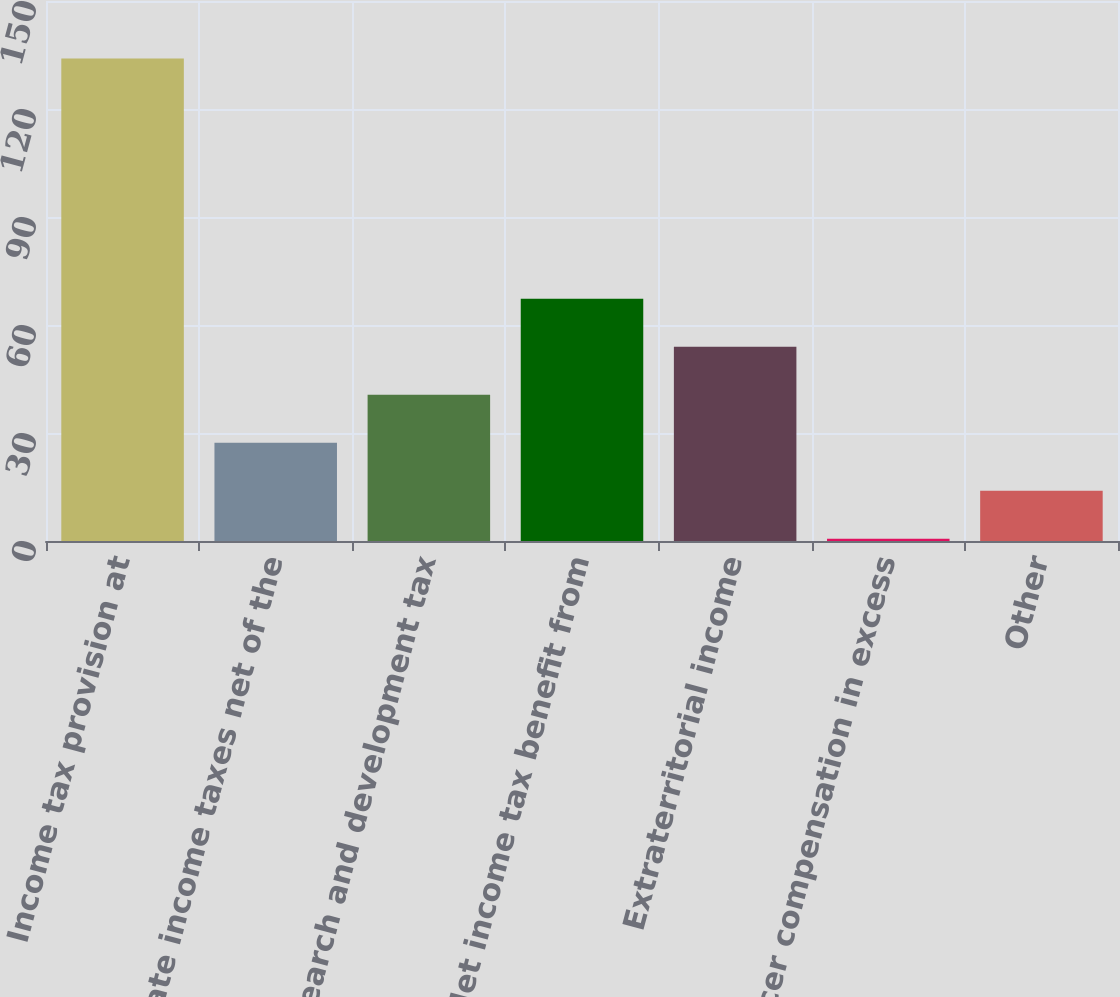Convert chart to OTSL. <chart><loc_0><loc_0><loc_500><loc_500><bar_chart><fcel>Income tax provision at<fcel>State income taxes net of the<fcel>Research and development tax<fcel>Net income tax benefit from<fcel>Extraterritorial income<fcel>Officer compensation in excess<fcel>Other<nl><fcel>134<fcel>27.28<fcel>40.62<fcel>67.3<fcel>53.96<fcel>0.6<fcel>13.94<nl></chart> 